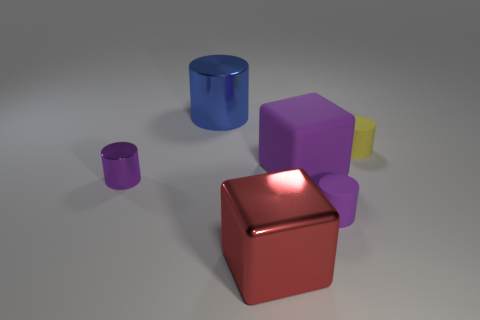There is a purple thing that is in front of the large purple matte cube and right of the blue object; what size is it?
Provide a short and direct response. Small. What is the shape of the red object?
Provide a succinct answer. Cube. What number of other things have the same shape as the yellow object?
Ensure brevity in your answer.  3. Is the number of tiny yellow cylinders that are in front of the red thing less than the number of big purple objects behind the tiny yellow object?
Your response must be concise. No. There is a purple cylinder on the left side of the big purple cube; what number of red blocks are behind it?
Your answer should be very brief. 0. Is there a small yellow metallic cylinder?
Offer a terse response. No. Is there a blue cylinder made of the same material as the big blue object?
Make the answer very short. No. Are there more big blue shiny cylinders that are in front of the yellow object than tiny yellow cylinders in front of the large metal cube?
Make the answer very short. No. Is the purple metal cylinder the same size as the blue metal thing?
Ensure brevity in your answer.  No. What is the color of the thing to the left of the large object behind the small yellow thing?
Ensure brevity in your answer.  Purple. 